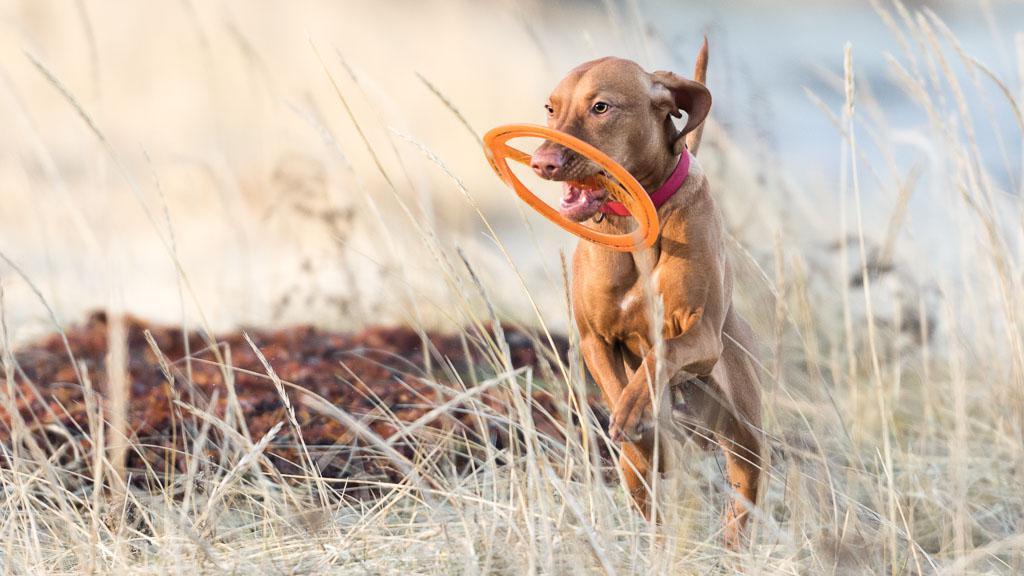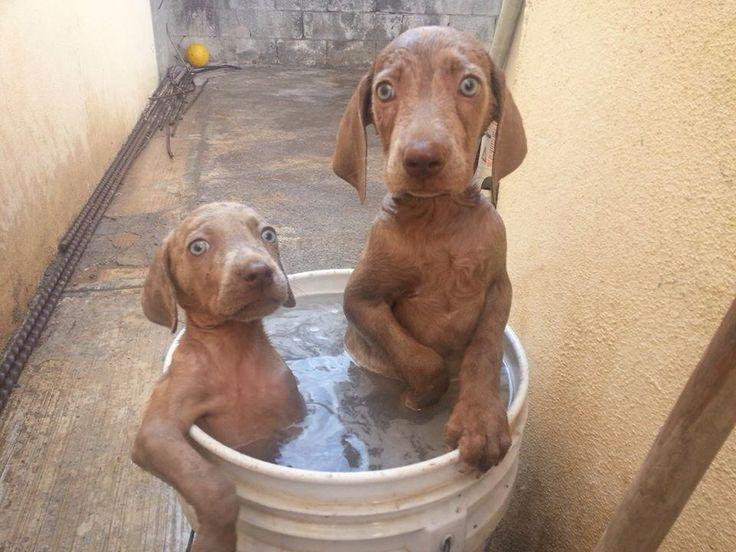The first image is the image on the left, the second image is the image on the right. Given the left and right images, does the statement "There are 3 or more dogs in one of the images." hold true? Answer yes or no. No. The first image is the image on the left, the second image is the image on the right. Considering the images on both sides, is "The right image shows multiple dogs in a container, with at least one paw over the edge on each side." valid? Answer yes or no. Yes. 